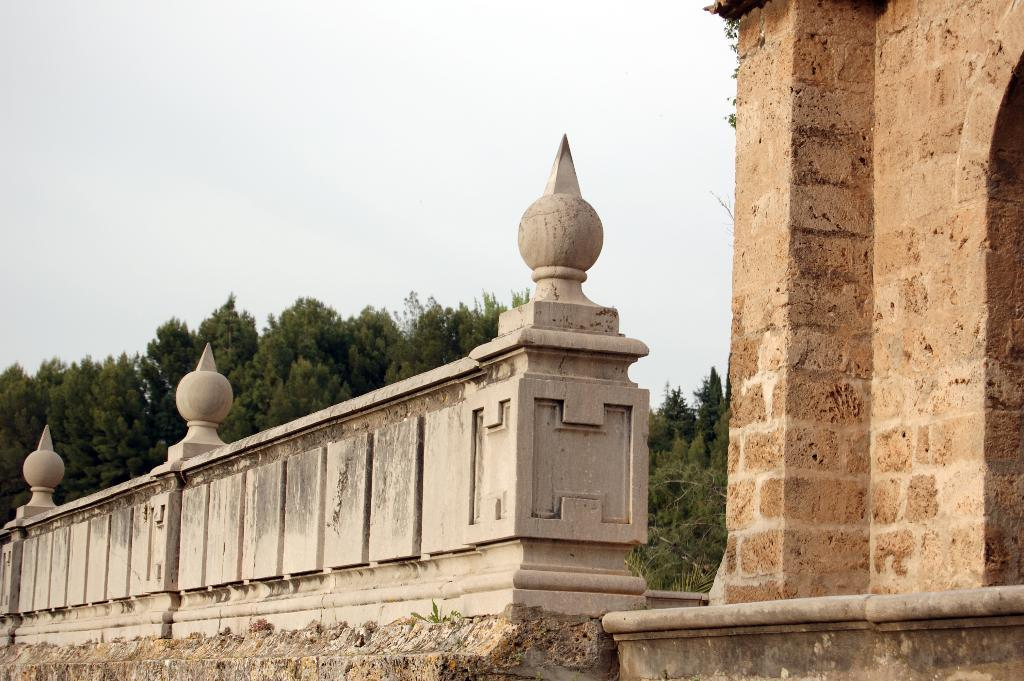What type of structure is present in the image? There is a building in the image. What is the purpose of the barrier in the image? There is a fence wall in the image, which serves as a barrier or boundary. What type of vegetation can be seen in the image? There are trees visible in the image. What is the condition of the sky in the image? The sky is cloudy in the image. What songs are being sung by the cows in the image? There are no cows present in the image, so there are no songs being sung by them. 